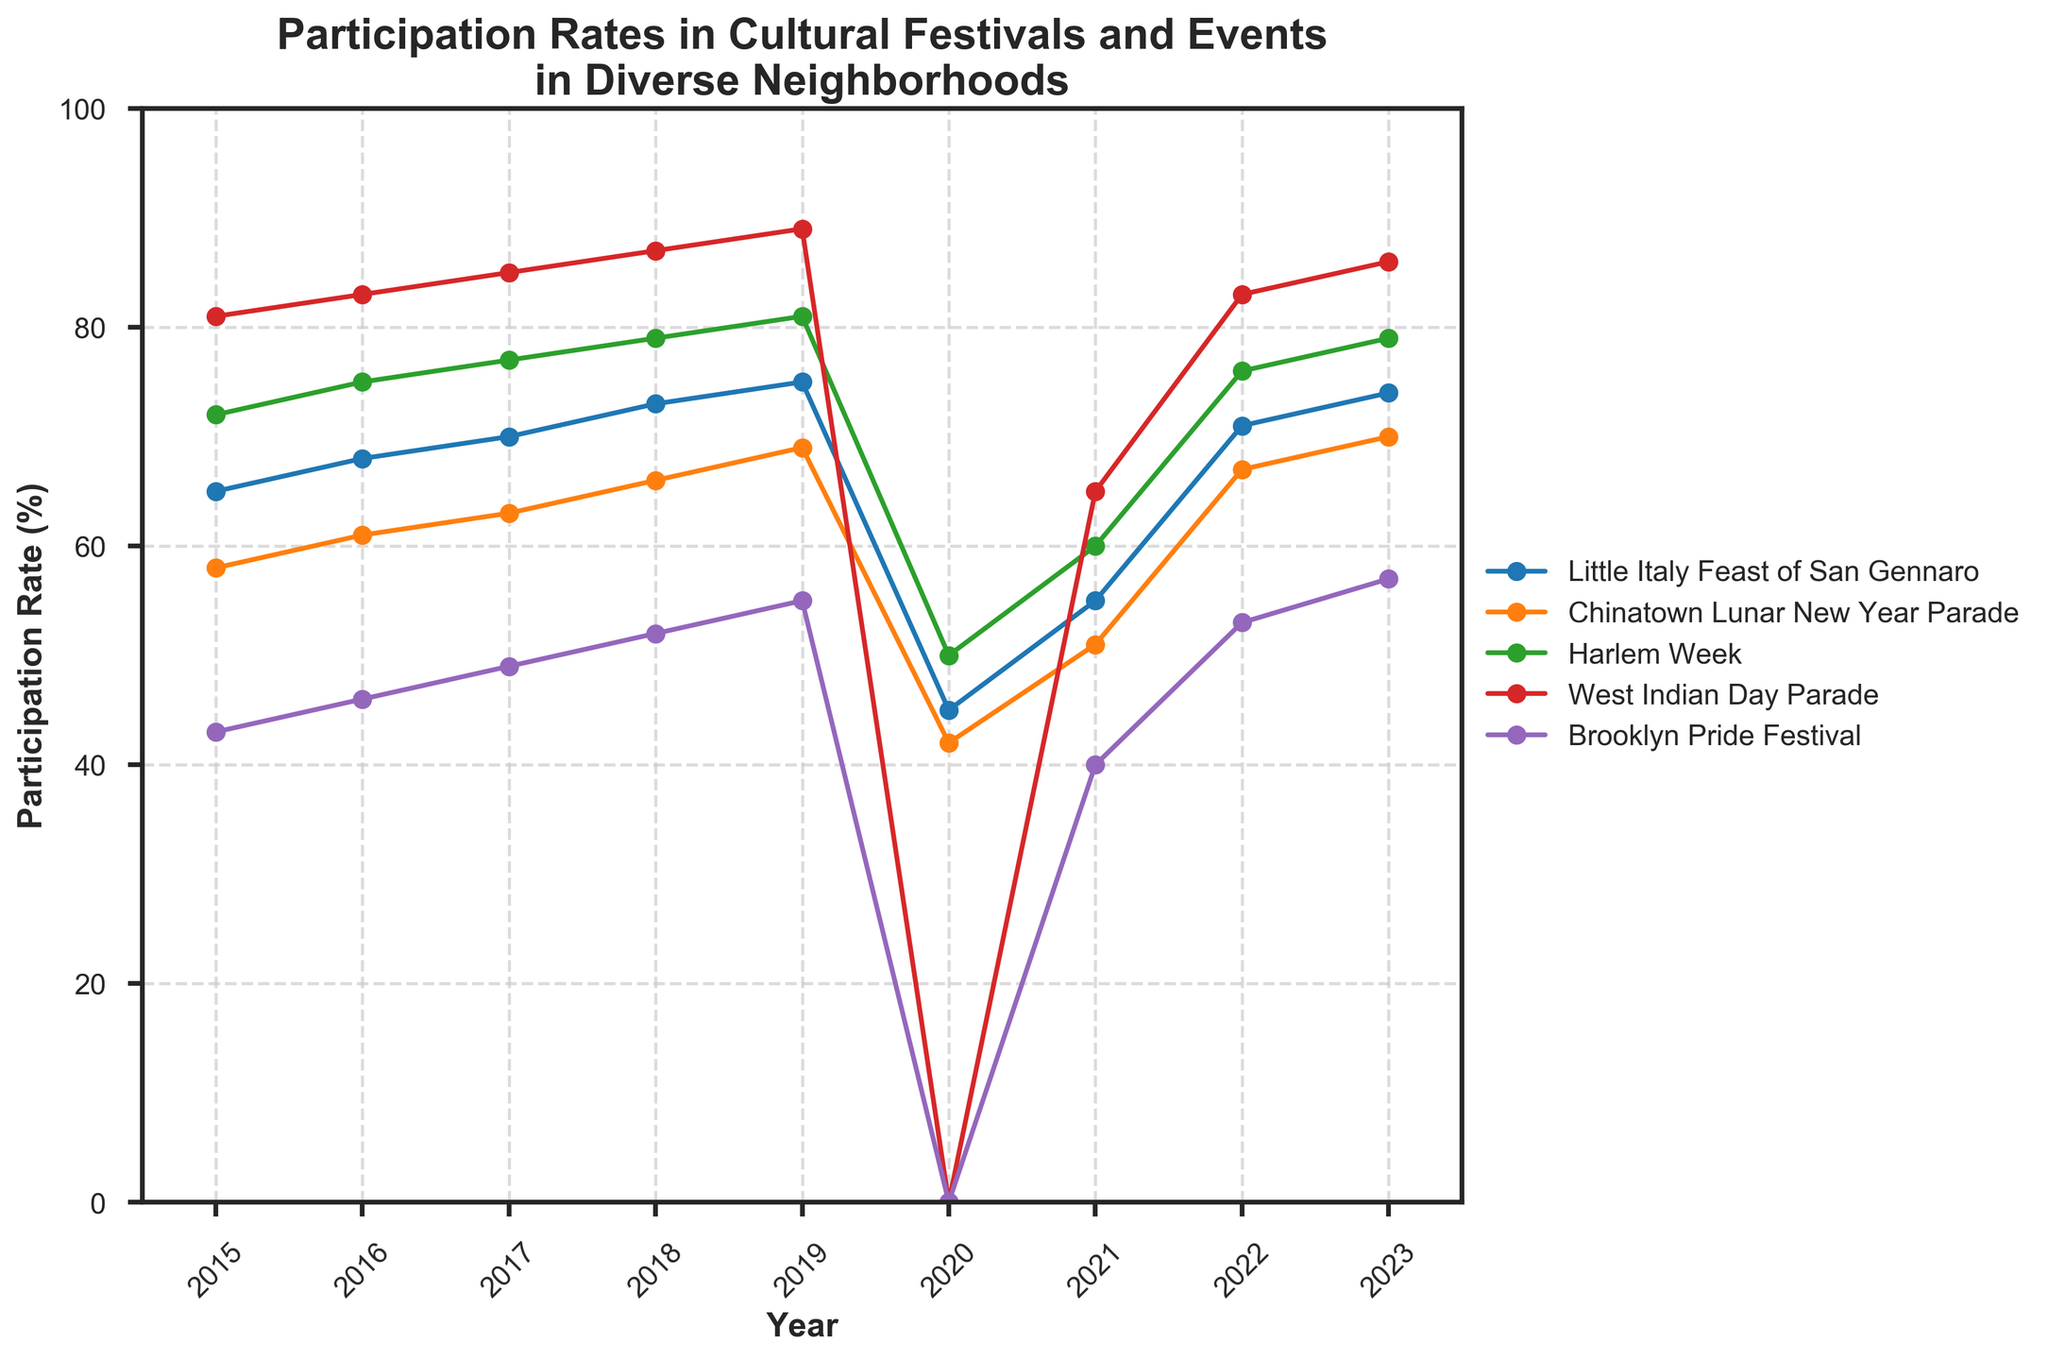Which event had the highest participation rate in 2019? The line for the participation rates in 2019 shows that the West Indian Day Parade had the highest value, peaking at 89%.
Answer: West Indian Day Parade How did the participation rate at the Brooklyn Pride Festival change from 2022 to 2023? Observing the line chart, the participation rate at the Brooklyn Pride Festival increased from 53% in 2022 to 57% in 2023.
Answer: Increased by 4% Which event experienced the most significant drop in participation rate from 2019 to 2020? The line chart shows that the West Indian Day Parade experienced the most significant drop, going from 89% in 2019 to 0% in 2020.
Answer: West Indian Day Parade What is the average participation rate across all events in 2023? Summing the participation rates in 2023 (74 + 70 + 79 + 86 + 57) equals 366, and dividing by the 5 events gives an average rate of 73.2%.
Answer: 73.2% Compare the participation rates of Little Italy Feast of San Gennaro and Chinatown Lunar New Year Parade in 2021. Which event had a higher participation rate? In 2021, the line chart shows the participation rate for Little Italy Feast of San Gennaro was 55%, whereas for the Chinatown Lunar New Year Parade, it was 51%. Little Italy Feast of San Gennaro had a higher rate.
Answer: Little Italy Feast of San Gennaro What trend do you observe for Harlem Week from 2015 to 2023? The line for Harlem Week shows a general increase in participation rates from 72% in 2015 to a peak of 81% in 2019, a dip in 2020 to 50%, and then recovering to 79% by 2023.
Answer: Increasing trend with a dip in 2020 and recovery afterward What is the total change in participation rate for the Chinatown Lunar New Year Parade from 2015 to 2023? The participation rate for the Chinatown Lunar New Year Parade increased from 58% in 2015 to 70% in 2023. The total change is 70 - 58 = 12%.
Answer: 12% In which year did the Brooklyn Pride Festival have the lowest participation rate? The line chart shows the lowest participation rate for the Brooklyn Pride Festival occurred in 2020, at 0%.
Answer: 2020 What is the visual pattern of the participation rate for the West Indian Day Parade before and after 2020? The West Indian Day Parade shows high participation rates leading up to 2020, peaking at 89%, then a significant drop to 0% in 2020, and a rapid recovery to 86% by 2023.
Answer: High before 2020, significant drop in 2020, and rapid recovery Which events showed a recovery in participation rates post-2020, and what is the general pattern observed? All events (Little Italy Feast of San Gennaro, Chinatown Lunar New Year Parade, Harlem Week, West Indian Day Parade, Brooklyn Pride Festival) showed a recovery in participation rates post-2020 with a generally increasing trend in the years 2021 to 2023.
Answer: All events showed recovery with an increasing trend 